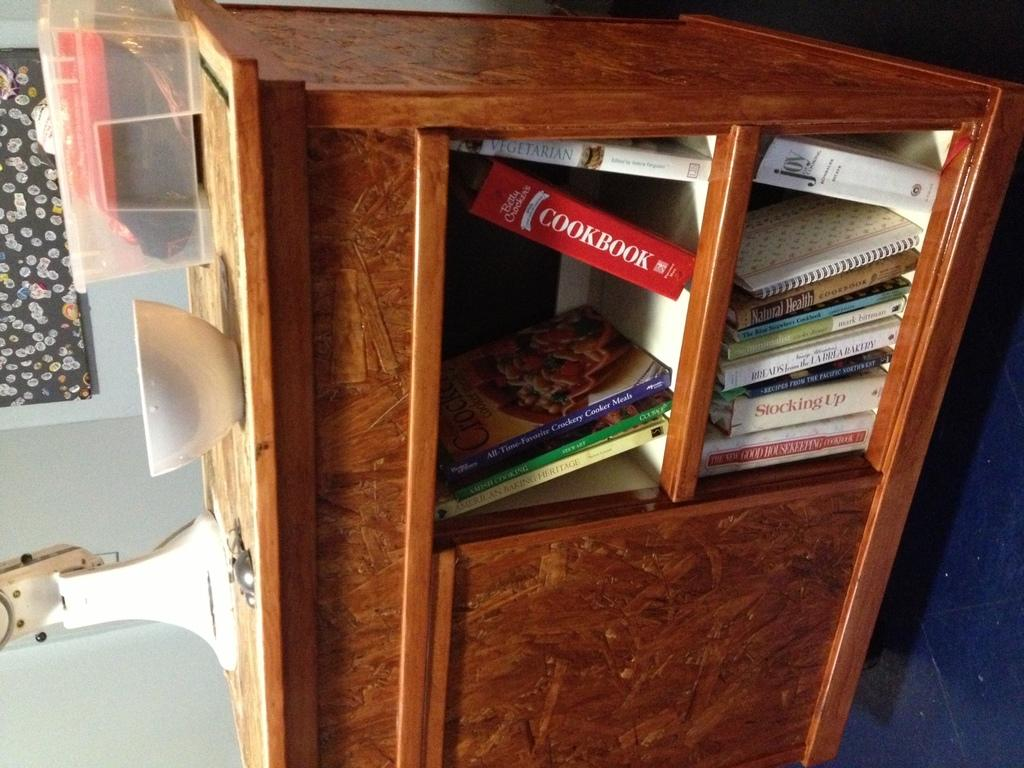What is stored on the cupboard in the image? There is a bowl and a plastic box on the cupboard, along with books. What color is the bowl on the cupboard? The provided facts do not mention the color of the bowl. What type of item is white and on the cupboard? There is a white color item on the cupboard, but the facts do not specify what it is. What is the color of the item on the wall behind the cupboard? There is a black color item on the wall behind the cupboard. What type of bun is sitting on the chin of the person in the image? There is no person present in the image, and therefore no bun or chin can be observed. 